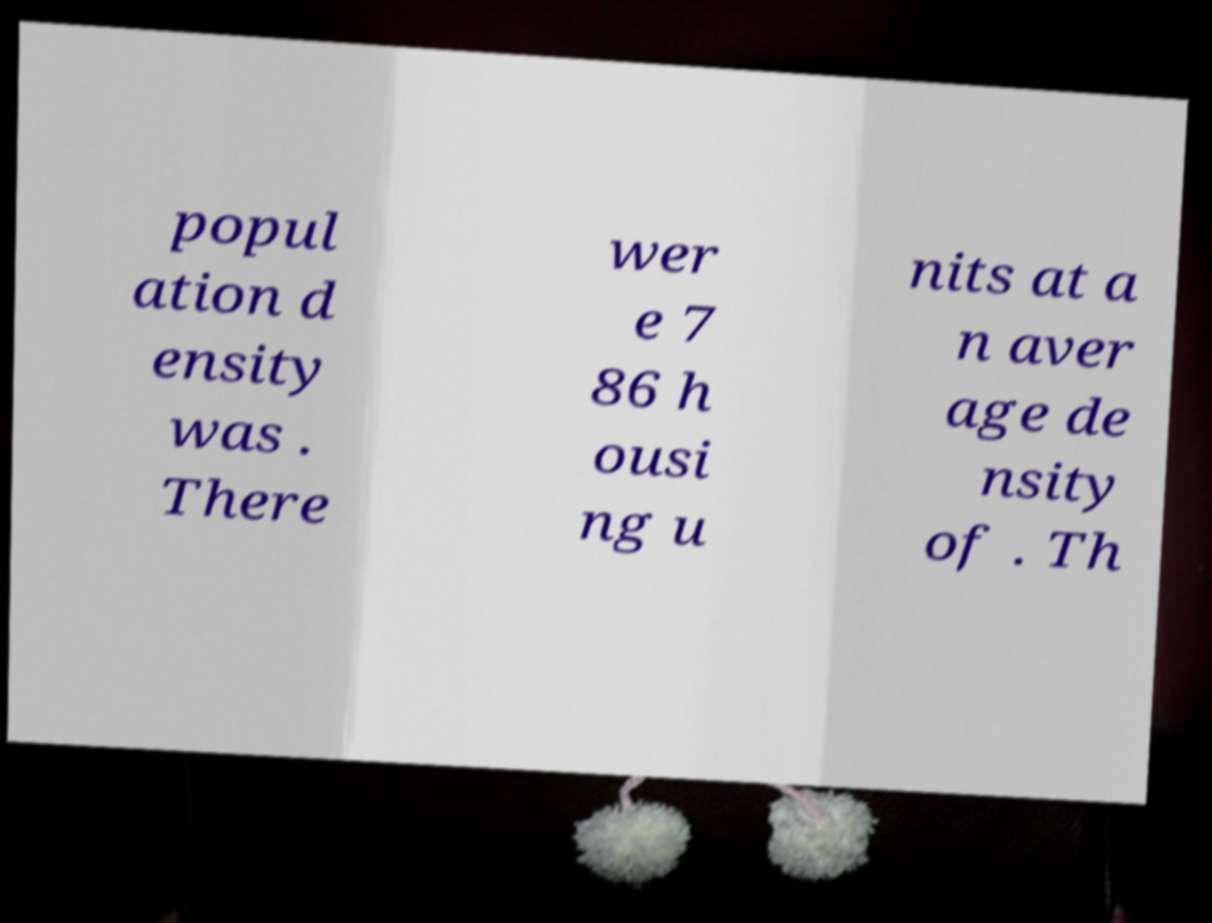Can you read and provide the text displayed in the image?This photo seems to have some interesting text. Can you extract and type it out for me? popul ation d ensity was . There wer e 7 86 h ousi ng u nits at a n aver age de nsity of . Th 